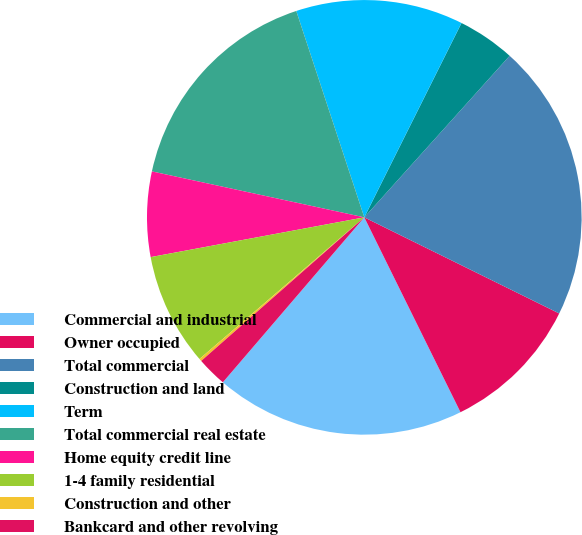Convert chart to OTSL. <chart><loc_0><loc_0><loc_500><loc_500><pie_chart><fcel>Commercial and industrial<fcel>Owner occupied<fcel>Total commercial<fcel>Construction and land<fcel>Term<fcel>Total commercial real estate<fcel>Home equity credit line<fcel>1-4 family residential<fcel>Construction and other<fcel>Bankcard and other revolving<nl><fcel>18.58%<fcel>10.41%<fcel>20.63%<fcel>4.28%<fcel>12.45%<fcel>16.54%<fcel>6.32%<fcel>8.37%<fcel>0.19%<fcel>2.23%<nl></chart> 